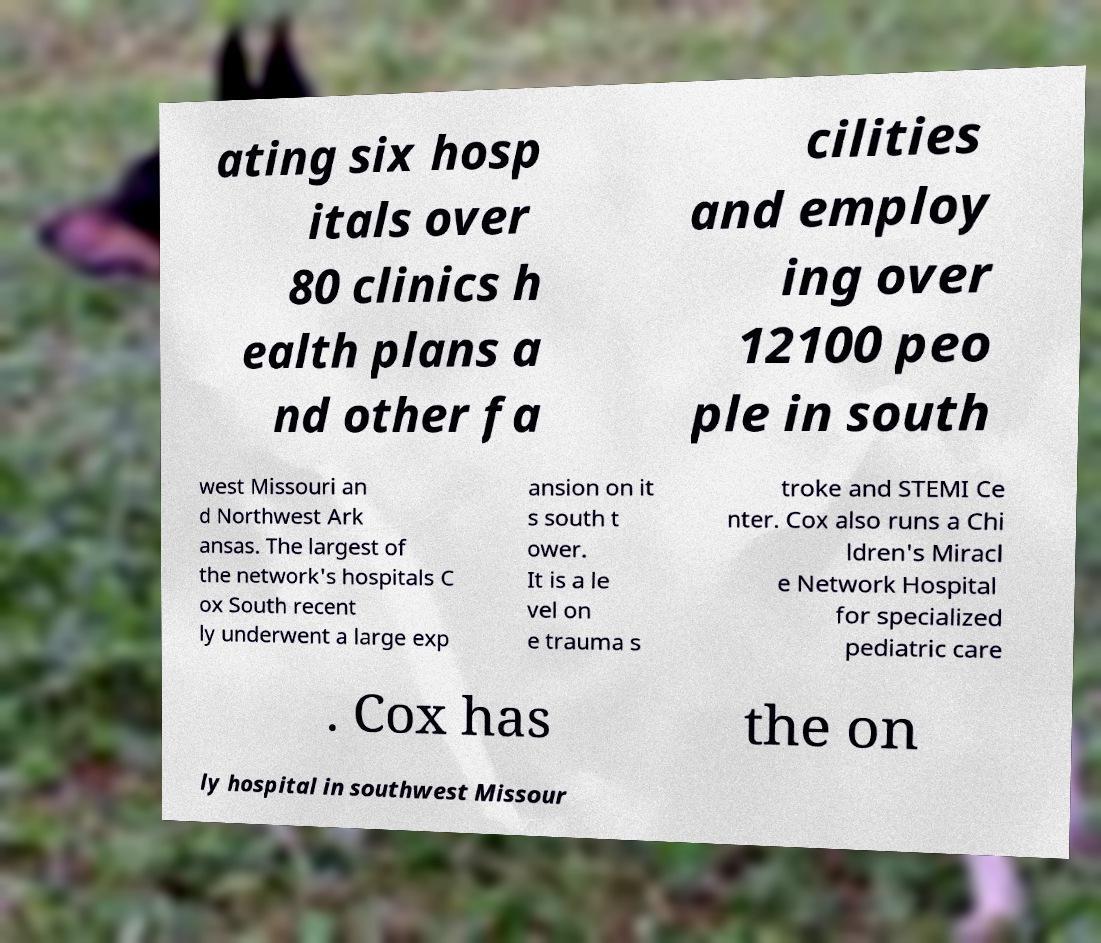Could you assist in decoding the text presented in this image and type it out clearly? ating six hosp itals over 80 clinics h ealth plans a nd other fa cilities and employ ing over 12100 peo ple in south west Missouri an d Northwest Ark ansas. The largest of the network's hospitals C ox South recent ly underwent a large exp ansion on it s south t ower. It is a le vel on e trauma s troke and STEMI Ce nter. Cox also runs a Chi ldren's Miracl e Network Hospital for specialized pediatric care . Cox has the on ly hospital in southwest Missour 